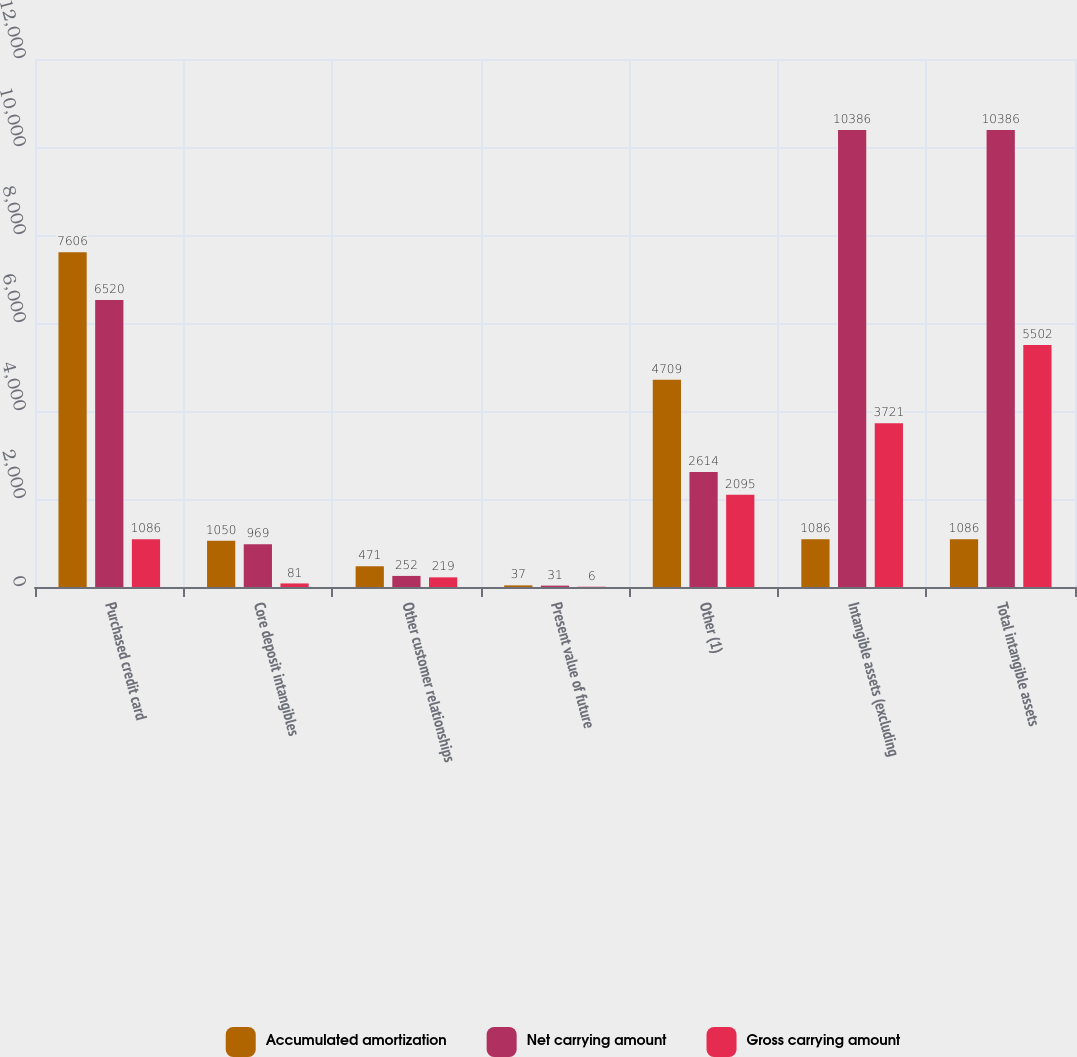Convert chart. <chart><loc_0><loc_0><loc_500><loc_500><stacked_bar_chart><ecel><fcel>Purchased credit card<fcel>Core deposit intangibles<fcel>Other customer relationships<fcel>Present value of future<fcel>Other (1)<fcel>Intangible assets (excluding<fcel>Total intangible assets<nl><fcel>Accumulated amortization<fcel>7606<fcel>1050<fcel>471<fcel>37<fcel>4709<fcel>1086<fcel>1086<nl><fcel>Net carrying amount<fcel>6520<fcel>969<fcel>252<fcel>31<fcel>2614<fcel>10386<fcel>10386<nl><fcel>Gross carrying amount<fcel>1086<fcel>81<fcel>219<fcel>6<fcel>2095<fcel>3721<fcel>5502<nl></chart> 